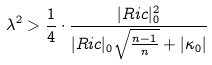Convert formula to latex. <formula><loc_0><loc_0><loc_500><loc_500>\lambda ^ { 2 } > \frac { 1 } { 4 } \cdot \frac { | R i c | ^ { 2 } _ { 0 } } { | R i c | _ { 0 } \sqrt { \frac { n - 1 } { n } } + | \kappa _ { 0 } | }</formula> 